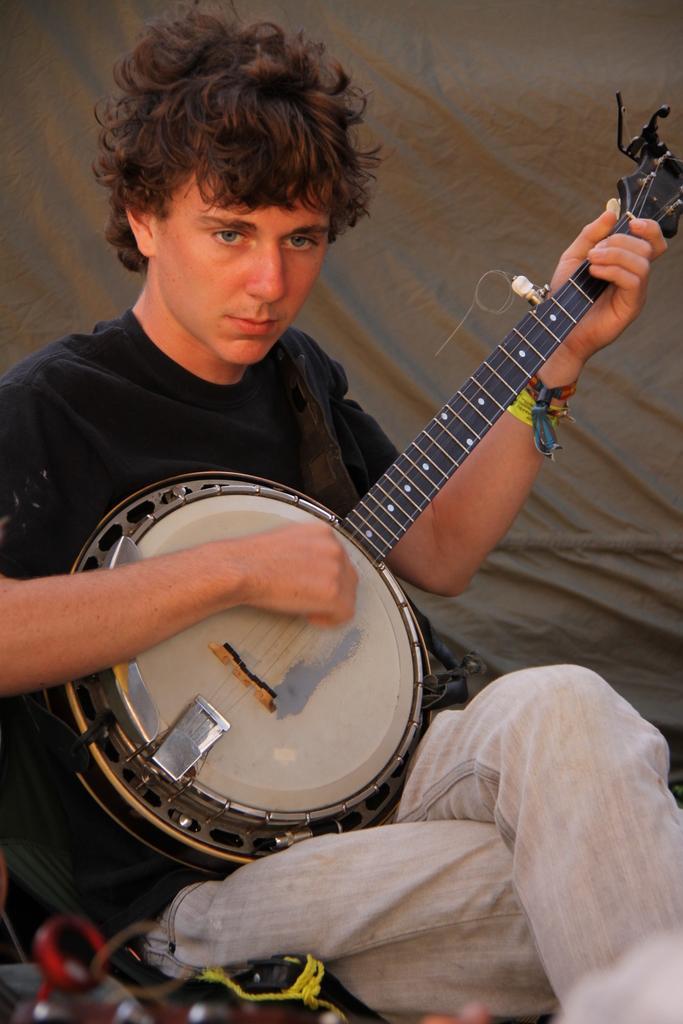Can you describe this image briefly? This image is taken indoors. In the background there is a cloth. In the middle of the image a man is sitting on the chair and he is holding a musical instrument in his hands and he is playing music. At the bottom of the image there are a few things. 